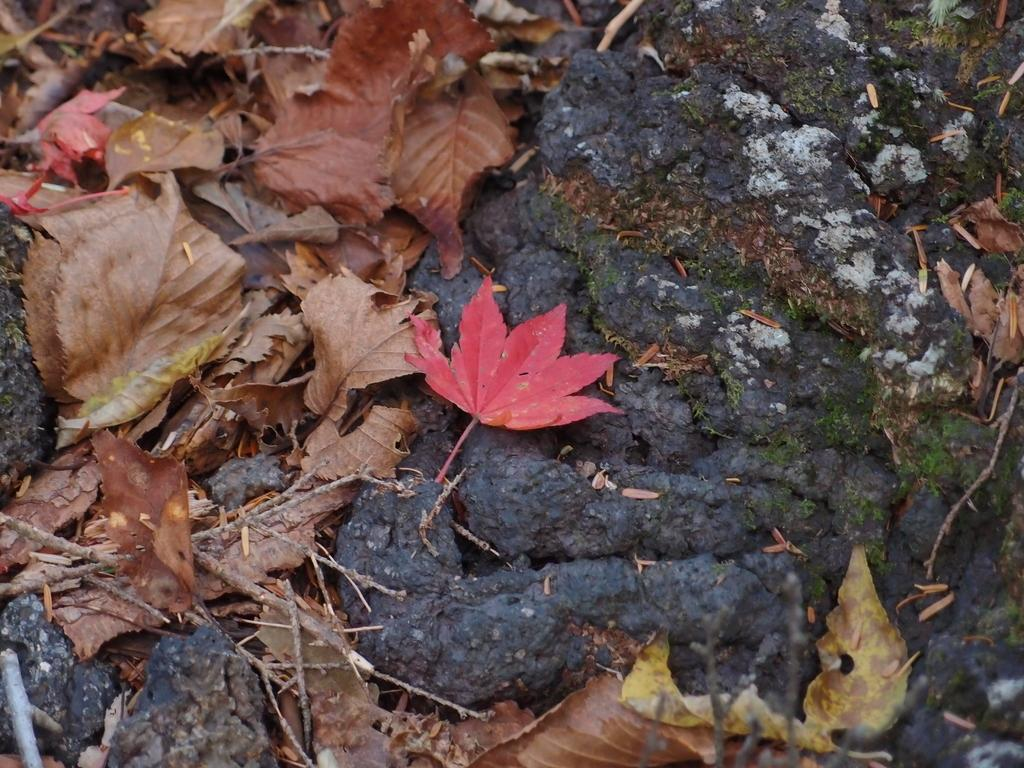What type of natural elements can be seen in the image? There are dried leaves in the image. Can you describe the condition of the leaves? The leaves appear to be dried. What might be the cause of the leaves being in this condition? The leaves may have been dried due to a lack of moisture or exposure to sunlight. What type of sound can be heard coming from the leaves in the image? There is no sound present in the image, as it is a still image of dried leaves. 